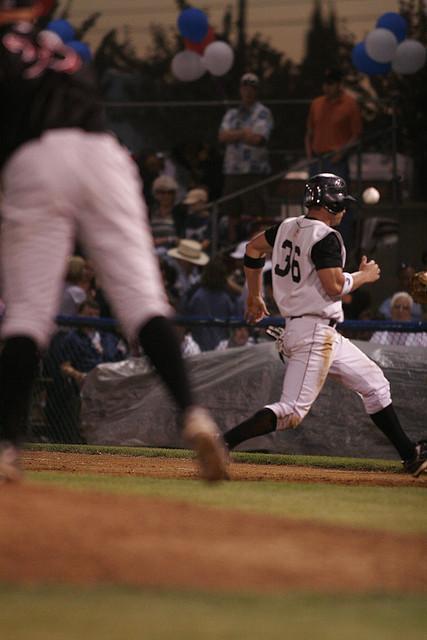How many people are in the photo?
Give a very brief answer. 6. 